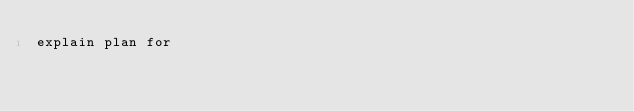<code> <loc_0><loc_0><loc_500><loc_500><_SQL_>explain plan for 
</code> 